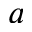<formula> <loc_0><loc_0><loc_500><loc_500>a</formula> 